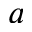<formula> <loc_0><loc_0><loc_500><loc_500>a</formula> 